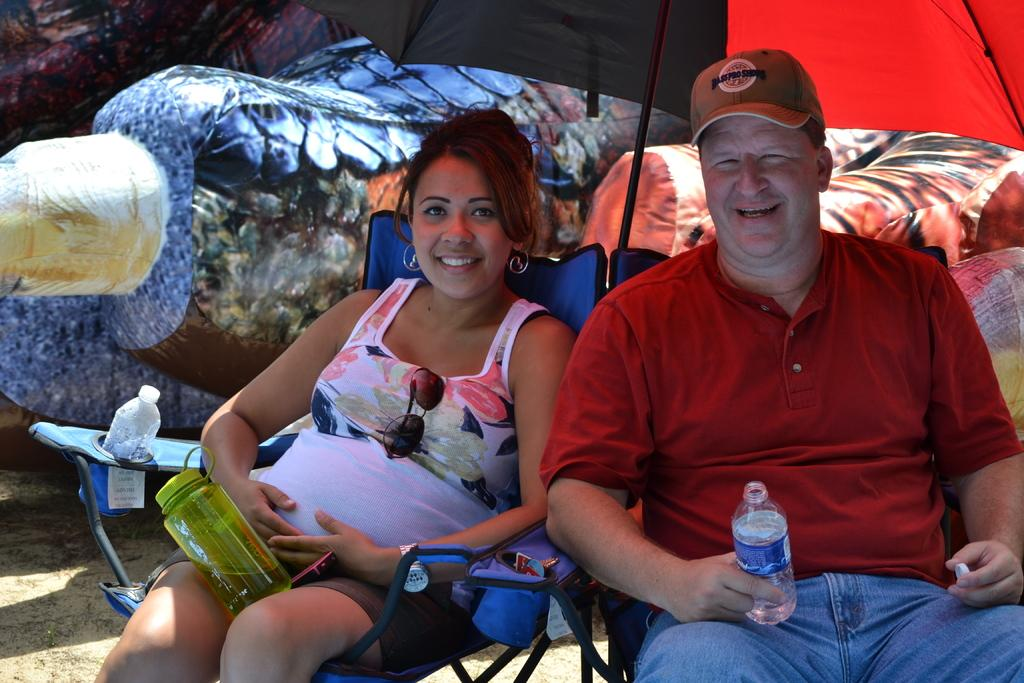Who is present in the image? There is a woman and a man in the image. What are they doing in the image? Both the woman and man are sitting on foldable chairs. Where are they sitting in the image? They are sitting under a tent. What are they holding in their hands? They are holding bottles in their hands. What color is the scarf worn by the sisters in the image? There are no sisters or scarves present in the image. On which channel can the event in the image be watched? There is no event or channel mentioned in the image. 